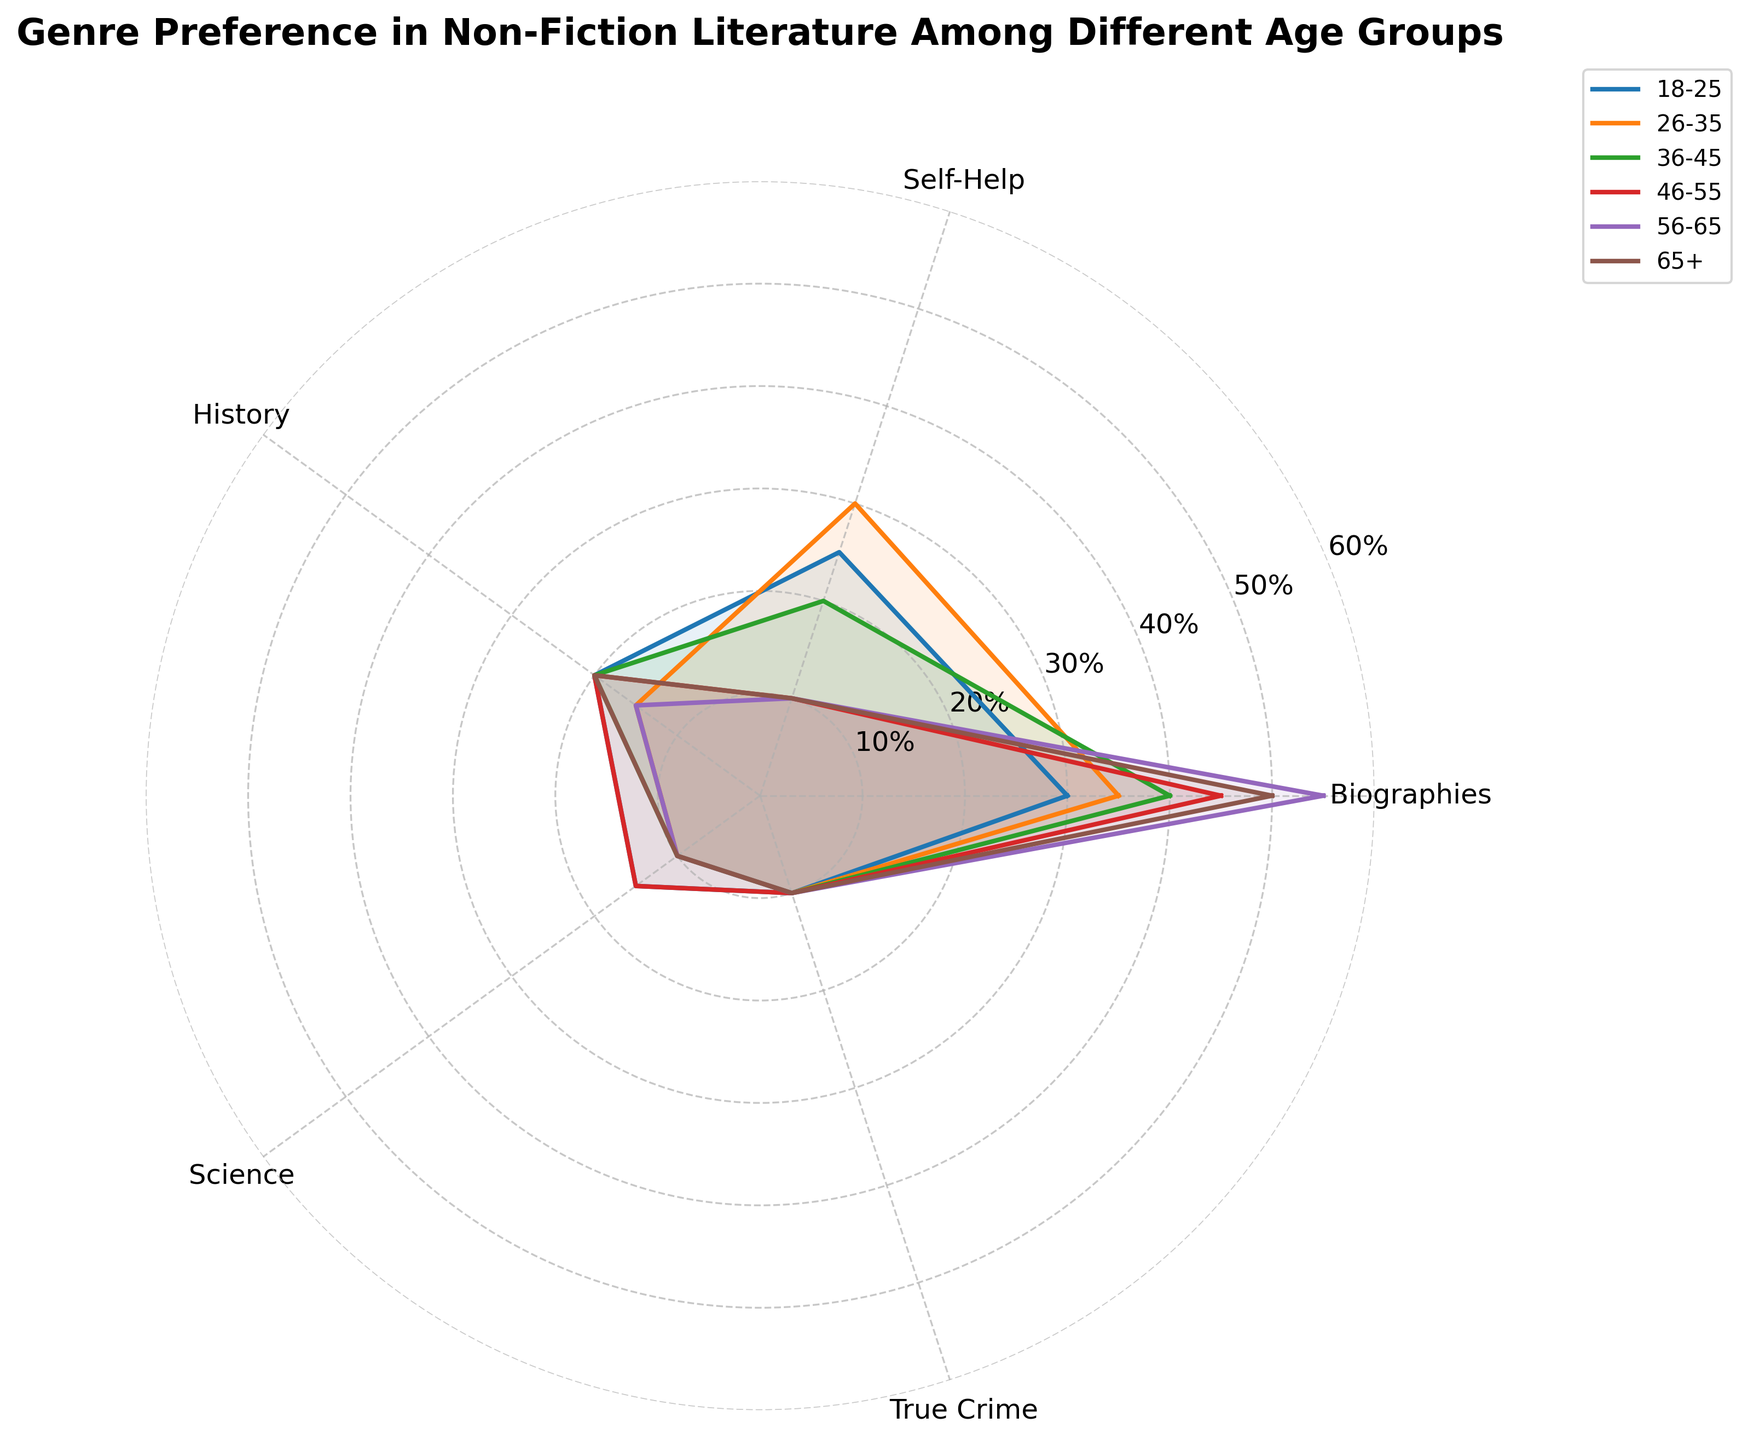What's the most preferred genre for the age group 56-65? The 56-65 age group shows the highest percentage for Biographies among all genres. Biographies is the top preference with a value of 55%.
Answer: Biographies Which age group has the least preference for Self-Help books? By comparing all the age groups' preferences for Self-Help, the 46-55, 56-65, and 65+ groups each have the lowest percentage, which is 10%.
Answer: 46-55, 56-65, 65+ What is the sum of the preferences for the True Crime genre across all age groups? Adding up the percentages of True Crime across each age group (10 + 10 + 10 + 10 + 10 + 10) results in a total of 60%.
Answer: 60% Which genre is equally preferred by the 18-25 and 36-45 age groups? By examining each genre, History shows an equal preference from both age groups, each with a 20% preference.
Answer: History What's the average preference for Science across all age groups? Adding the percentages of Science for all age groups (15 + 10 + 10 + 15 + 10 + 10) gives a total of 70%. Dividing by the number of age groups (6), the average preference is approximately 11.67%.
Answer: 11.67% How does the preference for History compare between the 18-25 and 26-35 age groups? The 18-25 age group has a History preference of 20%, whereas the 26-35 age group has a preference of 15%. The 18-25 age group has a higher preference for History.
Answer: 18-25 > 26-35 Which age group has the highest preference for Biographies? Looking at all age groups, the 56-65 age group has the highest Biographies preference of 55%.
Answer: 56-65 What's the difference in preference for Self-Help books between the 26-35 and 36-45 age groups? The 26-35 age group has a Self-Help preference of 30%, whereas the 36-45 age group has a preference of 20%. The difference is 30% - 20% = 10%.
Answer: 10% Which genres do the age group 65+ prefer the least? In the 65+ age group, the lowest preferences are for Self-Help, Science, and True Crime, each with 10%.
Answer: Self-Help, Science, True Crime 